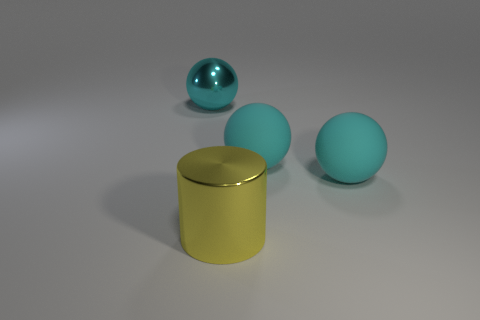How many cyan spheres must be subtracted to get 1 cyan spheres? 2 Subtract all big cyan shiny balls. How many balls are left? 2 Add 1 rubber objects. How many objects exist? 5 Subtract all balls. How many objects are left? 1 Subtract 2 spheres. How many spheres are left? 1 Add 4 big metallic things. How many big metallic things are left? 6 Add 3 cylinders. How many cylinders exist? 4 Subtract 0 green cylinders. How many objects are left? 4 Subtract all blue balls. Subtract all red cylinders. How many balls are left? 3 Subtract all big red matte blocks. Subtract all cylinders. How many objects are left? 3 